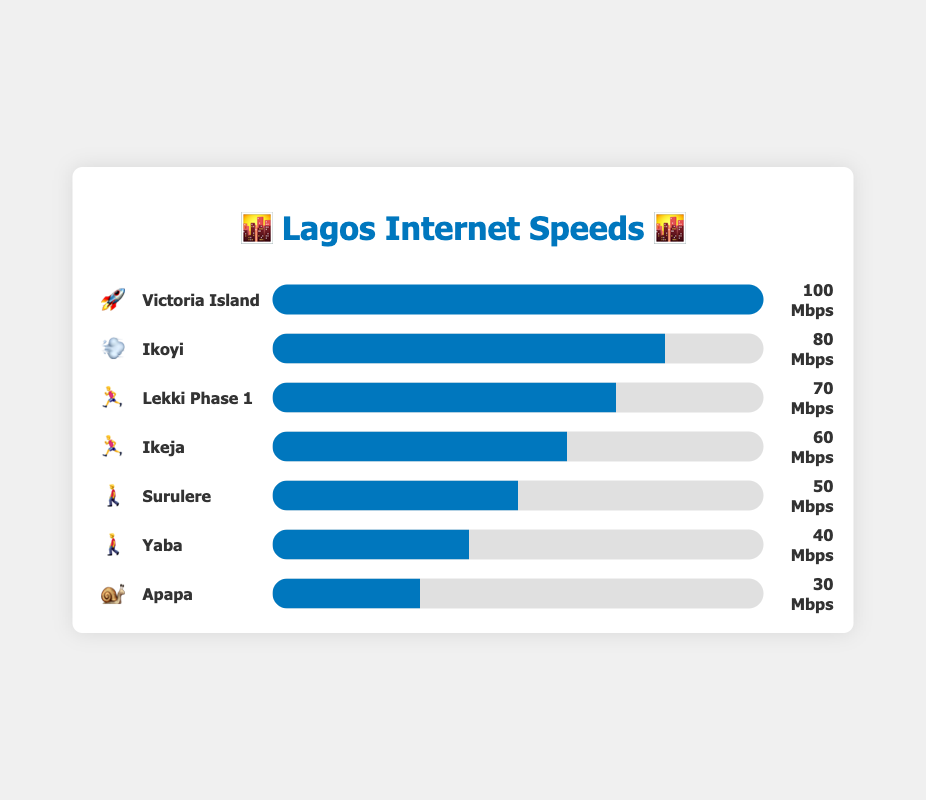What's the fastest internet speed shown in the chart and which neighborhood does it correspond to? The chart shows various internet speeds for different neighborhoods. Victoria Island has the highest speed of 100 Mbps, as indicated by the "🚀" emoji next to it.
Answer: 100 Mbps, Victoria Island Which neighborhood has the slowest internet speed and what is the speed? The chart lists internet speeds for several neighborhoods. Apapa has the slowest speed at 30 Mbps, marked by the "🐌" emoji.
Answer: 30 Mbps, Apapa How does the internet speed in Ikoyi compare to that in Yaba? From the chart, Ikoyi has an internet speed of 80 Mbps and Yaba has 40 Mbps. Comparing these, Ikoyi's speed is higher.
Answer: Ikoyi's speed is higher What is the average internet speed across all listed neighborhoods? The sum of all internet speeds (100 + 80 + 70 + 60 + 50 + 40 + 30) is 430 Mbps. There are 7 neighborhoods, so the average speed is 430 / 7 ≈ 61.4 Mbps.
Answer: 61.4 Mbps Which neighborhoods have speeds greater than 60 Mbps? The chart indicates the speeds for various neighborhoods. Those with speeds greater than 60 Mbps are Victoria Island (100 Mbps), Ikoyi (80 Mbps), and Lekki Phase 1 (70 Mbps).
Answer: Victoria Island, Ikoyi, Lekki Phase 1 What's the total internet speed for Surulere and Yaba combined? Surulere has a speed of 50 Mbps and Yaba has 40 Mbps. Combined, their total speed is 50 + 40 = 90 Mbps.
Answer: 90 Mbps List the neighborhoods in descending order based on their internet speeds. The chart details speeds for different neighborhoods. Arranged from highest to lowest: Victoria Island (100), Ikoyi (80), Lekki Phase 1 (70), Ikeja (60), Surulere (50), Yaba (40), Apapa (30).
Answer: Victoria Island, Ikoyi, Lekki Phase 1, Ikeja, Surulere, Yaba, Apapa How much faster is Victoria Island's internet compared to Apapa's? Victoria Island has 100 Mbps and Apapa has 30 Mbps. The difference is 100 - 30 = 70 Mbps.
Answer: 70 Mbps faster What is the median internet speed of the listed neighborhoods? Arranging the speeds in ascending order (30, 40, 50, 60, 70, 80, 100), the median speed is the middle value, which is the fourth number: 60 Mbps.
Answer: 60 Mbps 